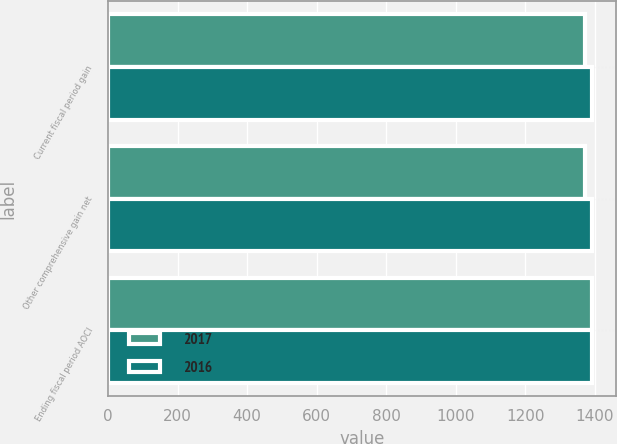Convert chart to OTSL. <chart><loc_0><loc_0><loc_500><loc_500><stacked_bar_chart><ecel><fcel>Current fiscal period gain<fcel>Other comprehensive gain net<fcel>Ending fiscal period AOCI<nl><fcel>2017<fcel>1371<fcel>1371<fcel>1392<nl><fcel>2016<fcel>1392<fcel>1392<fcel>1392<nl></chart> 